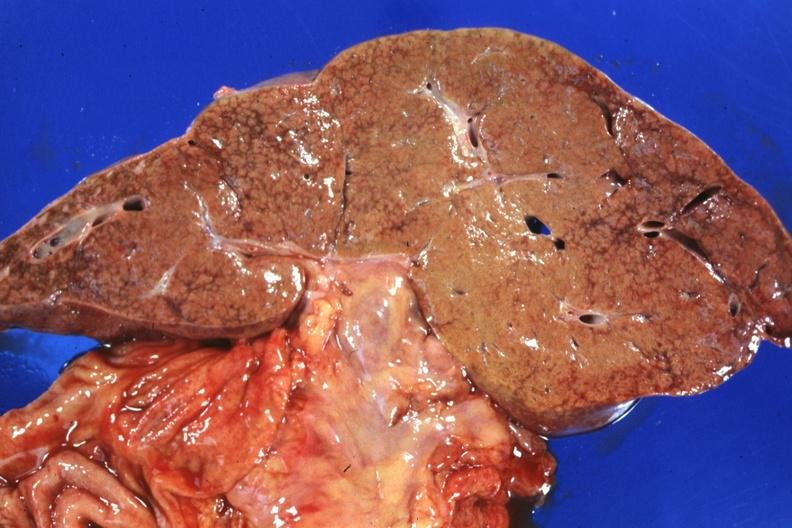s liver present?
Answer the question using a single word or phrase. Yes 